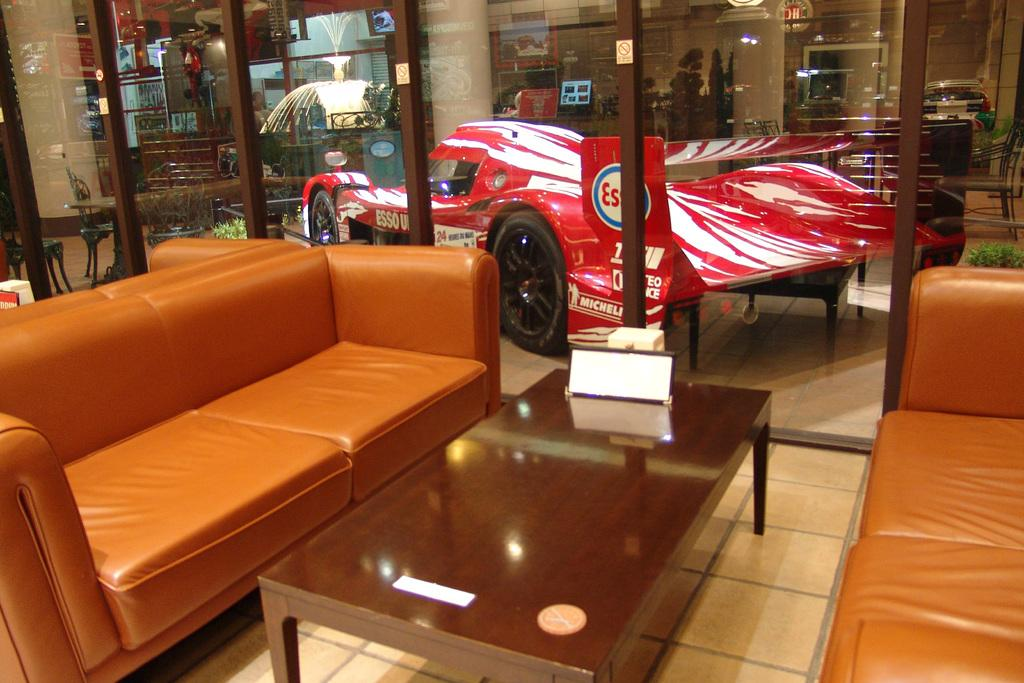What type of space is depicted in the image? There is a room in the image. What furniture is present in the room? There is a sofa and a table in the room. How are the sofa and table arranged in the room? The table is in front of the sofa. What can be seen outside the room in the image? There is a car near the room. What other items can be found in the room? There are many items present in the room. What type of ground is visible beneath the car in the image? There is no ground visible beneath the car in the image; it appears to be parked on a paved surface or driveway. What emotion does the sofa express in the image? The sofa is an inanimate object and does not express emotions like regret. 